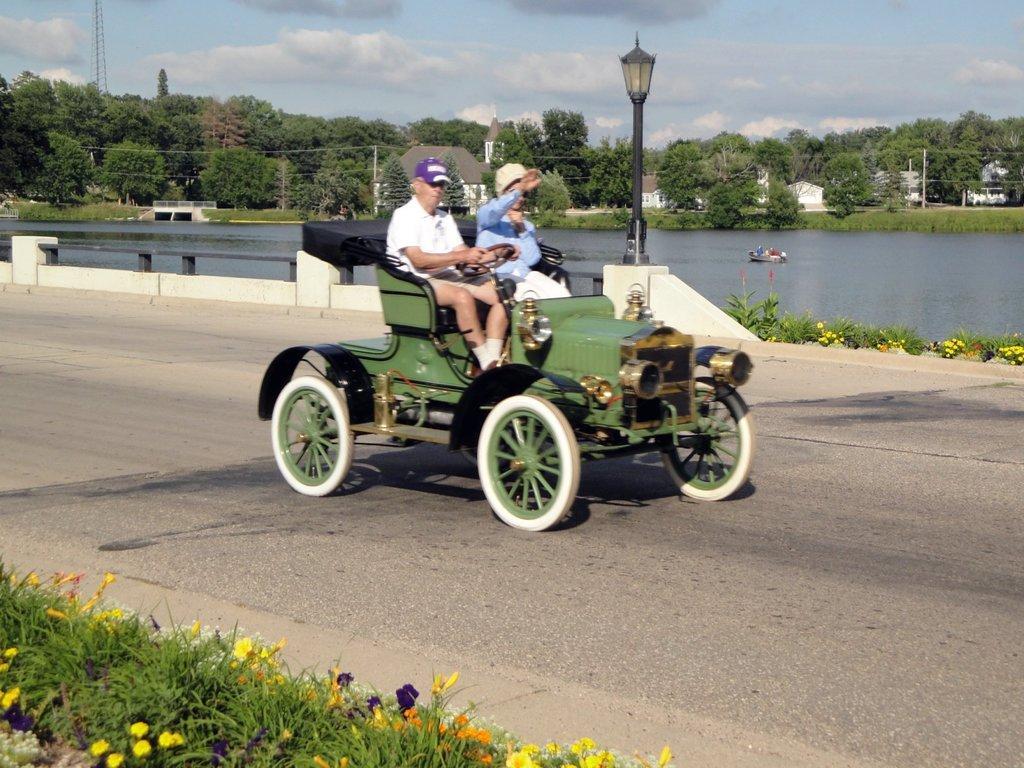In one or two sentences, can you explain what this image depicts? In this image there are two people travelling in a car on the road, in front of the image there are flowers on the plants, on the other side of the road there is a lamp post on the concrete fence, beside the lamp there are flowers on the plant, in the background of the image there is a boat in the river, on the other side of the river there are trees, houses, electric poles with cables on it, a tower, at the top of the image there are clouds in the sky. 